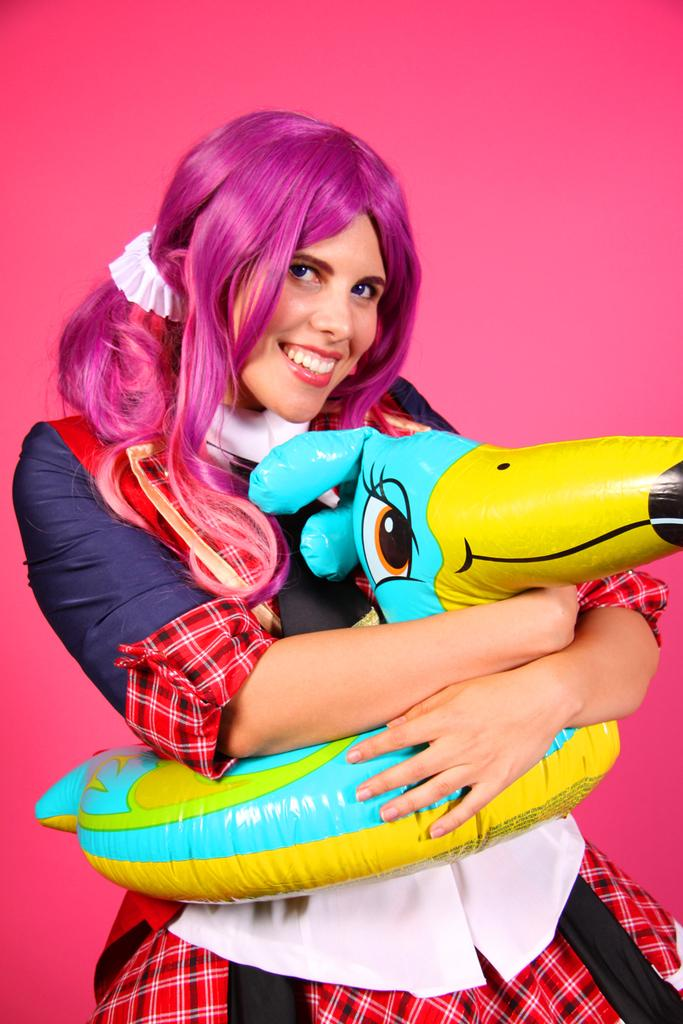Who is present in the image? There is a woman in the image. What is the woman doing in the image? The woman is holding an object and smiling. What color is the background of the image? The background of the image is pink in color. What type of organization can be seen in the background of the image? There is no organization visible in the image; the background is pink in color. 